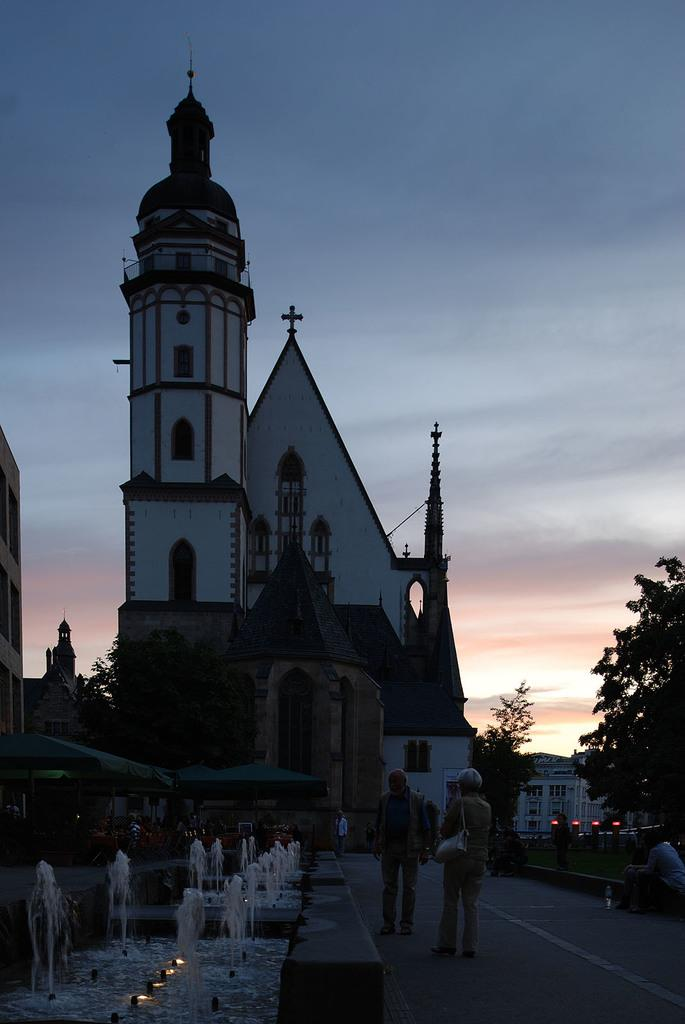What can be seen on the ground in the image? There are people on the pathway in the image. What can be seen illuminating the area in the image? There are lights visible in the image. What type of water feature is present in the image? There are fountains in the image. What type of structure is present in the image? There is a building in the image. What type of vegetation is present in the image? There are trees in the image. What is visible in the sky in the image? The sky is visible in the image, and it appears cloudy. What type of throat condition can be seen in the image? There is no throat condition present in the image. What type of nose is visible in the image? There is no nose visible in the image. 